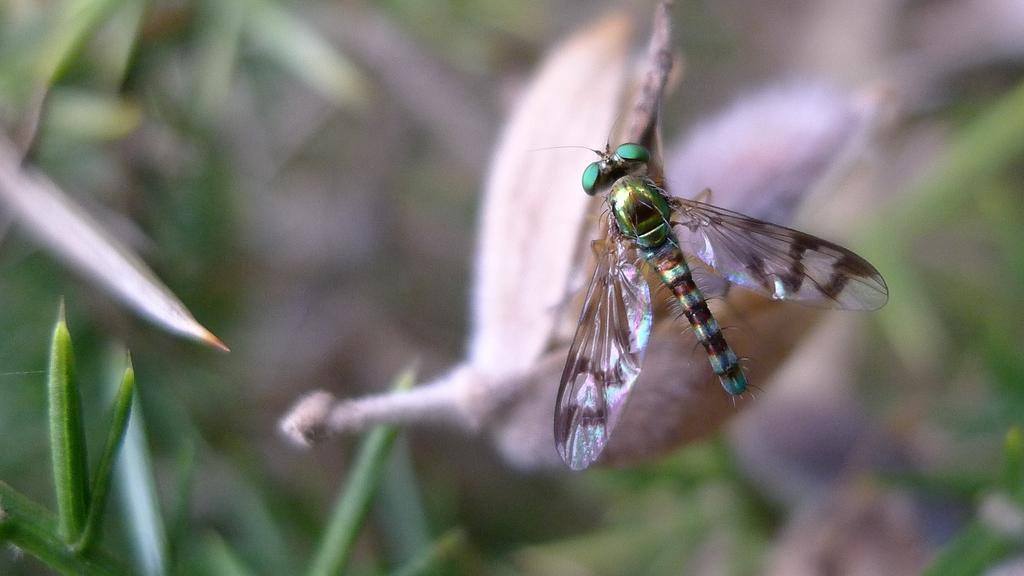Please provide a concise description of this image. This is a zoomed in picture. On the right there is a fly seems to be a grasshopper. The background of the image is blurry and we can see the plants in the background. 